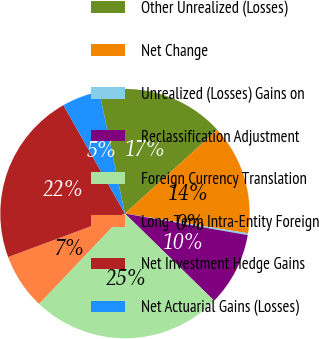Convert chart. <chart><loc_0><loc_0><loc_500><loc_500><pie_chart><fcel>Other Unrealized (Losses)<fcel>Net Change<fcel>Unrealized (Losses) Gains on<fcel>Reclassification Adjustment<fcel>Foreign Currency Translation<fcel>Long-Term Intra-Entity Foreign<fcel>Net Investment Hedge Gains<fcel>Net Actuarial Gains (Losses)<nl><fcel>16.59%<fcel>14.26%<fcel>0.24%<fcel>9.55%<fcel>24.79%<fcel>7.22%<fcel>22.46%<fcel>4.9%<nl></chart> 